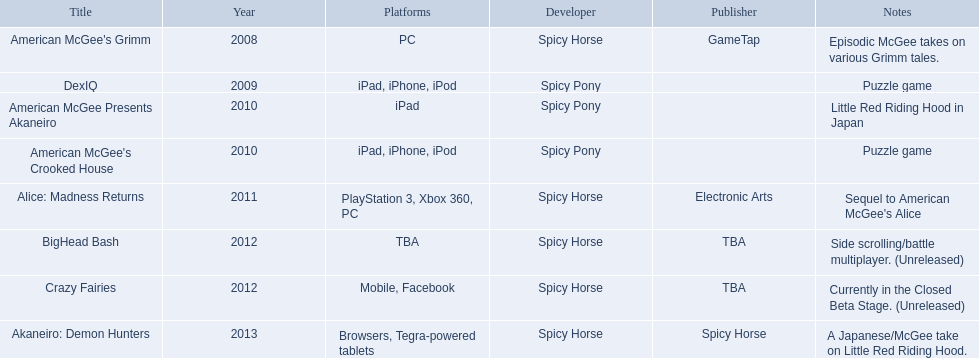What are all the titles? American McGee's Grimm, DexIQ, American McGee Presents Akaneiro, American McGee's Crooked House, Alice: Madness Returns, BigHead Bash, Crazy Fairies, Akaneiro: Demon Hunters. What platforms were they available on? PC, iPad, iPhone, iPod, iPad, iPad, iPhone, iPod, PlayStation 3, Xbox 360, PC, TBA, Mobile, Facebook, Browsers, Tegra-powered tablets. And which were available only on the ipad? American McGee Presents Akaneiro. 